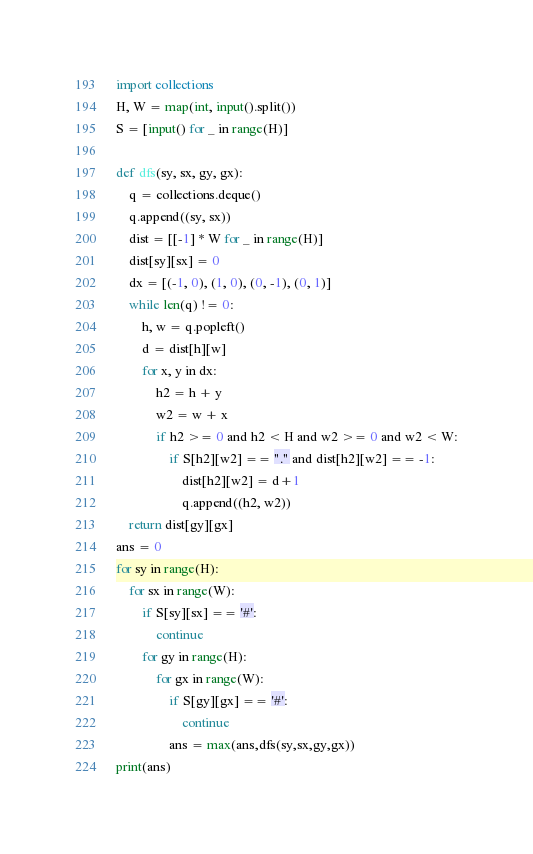<code> <loc_0><loc_0><loc_500><loc_500><_Python_>import collections
H, W = map(int, input().split())
S = [input() for _ in range(H)]

def dfs(sy, sx, gy, gx):
    q = collections.deque()
    q.append((sy, sx))
    dist = [[-1] * W for _ in range(H)]
    dist[sy][sx] = 0
    dx = [(-1, 0), (1, 0), (0, -1), (0, 1)]
    while len(q) != 0:
        h, w = q.popleft()
        d = dist[h][w]
        for x, y in dx:
            h2 = h + y
            w2 = w + x
            if h2 >= 0 and h2 < H and w2 >= 0 and w2 < W:
                if S[h2][w2] == "." and dist[h2][w2] == -1:
                    dist[h2][w2] = d+1
                    q.append((h2, w2))
    return dist[gy][gx]
ans = 0
for sy in range(H):
    for sx in range(W):
        if S[sy][sx] == '#':
            continue
        for gy in range(H):
            for gx in range(W):
                if S[gy][gx] == '#':
                    continue
                ans = max(ans,dfs(sy,sx,gy,gx))
print(ans)</code> 